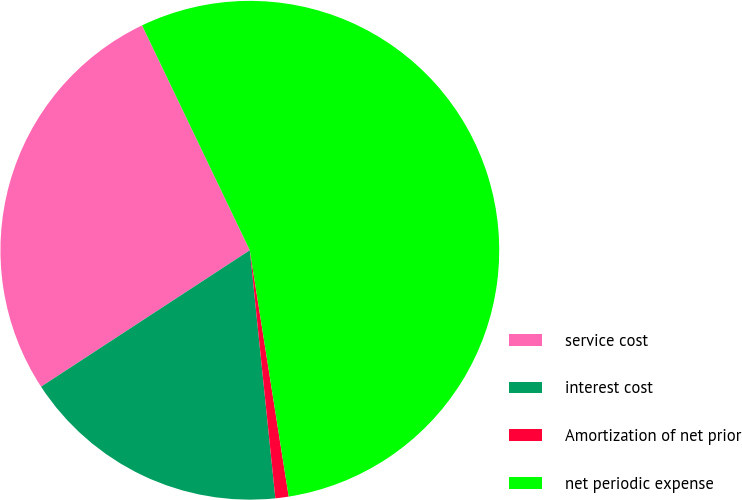Convert chart to OTSL. <chart><loc_0><loc_0><loc_500><loc_500><pie_chart><fcel>service cost<fcel>interest cost<fcel>Amortization of net prior<fcel>net periodic expense<nl><fcel>27.1%<fcel>17.42%<fcel>0.86%<fcel>54.62%<nl></chart> 